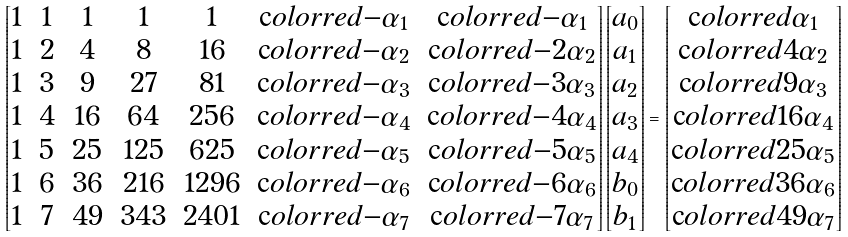Convert formula to latex. <formula><loc_0><loc_0><loc_500><loc_500>\begin{bmatrix} 1 & 1 & 1 & 1 & 1 & \text  color{red} { - \alpha _ { 1 } } & \text  color{red} { - \alpha _ { 1 } } \\ 1 & 2 & 4 & 8 & 1 6 & \text  color{red} { - \alpha _ { 2 } } & \text  color{red} { - 2 \alpha _ { 2 } } \\ 1 & 3 & 9 & 2 7 & 8 1 & \text  color{red} { - \alpha _ { 3 } } & \text  color{red} { - 3 \alpha _ { 3 } } \\ 1 & 4 & 1 6 & 6 4 & 2 5 6 & \text  color{red} { - \alpha _ { 4 } } & \text  color{red} { - 4 \alpha _ { 4 } } \\ 1 & 5 & 2 5 & 1 2 5 & 6 2 5 & \text  color{red} { - \alpha _ { 5 } } & \text  color{red} { - 5 \alpha _ { 5 } } \\ 1 & 6 & 3 6 & 2 1 6 & 1 2 9 6 & \text  color{red} { - \alpha _ { 6 } } & \text  color{red} { - 6 \alpha _ { 6 } } \\ 1 & 7 & 4 9 & 3 4 3 & 2 4 0 1 & \text  color{red} { - \alpha _ { 7 } } & \text  color{red} { - 7 \alpha _ { 7 } } \\ \end{bmatrix} \begin{bmatrix} a _ { 0 } \\ a _ { 1 } \\ a _ { 2 } \\ a _ { 3 } \\ a _ { 4 } \\ b _ { 0 } \\ b _ { 1 } \end{bmatrix} = \begin{bmatrix} \text  color{red} { \alpha _ { 1 } } \\ \text  color{red} { 4 \alpha _ { 2 } } \\ \text  color{red} { 9 \alpha _ { 3 } } \\ \text  color{red} { 1 6 \alpha _ { 4 } } \\ \text  color{red} { 2 5 \alpha _ { 5 } } \\ \text  color{red} { 3 6 \alpha _ { 6 } } \\ \text  color{red} { 4 9 \alpha _ { 7 } } \end{bmatrix}</formula> 